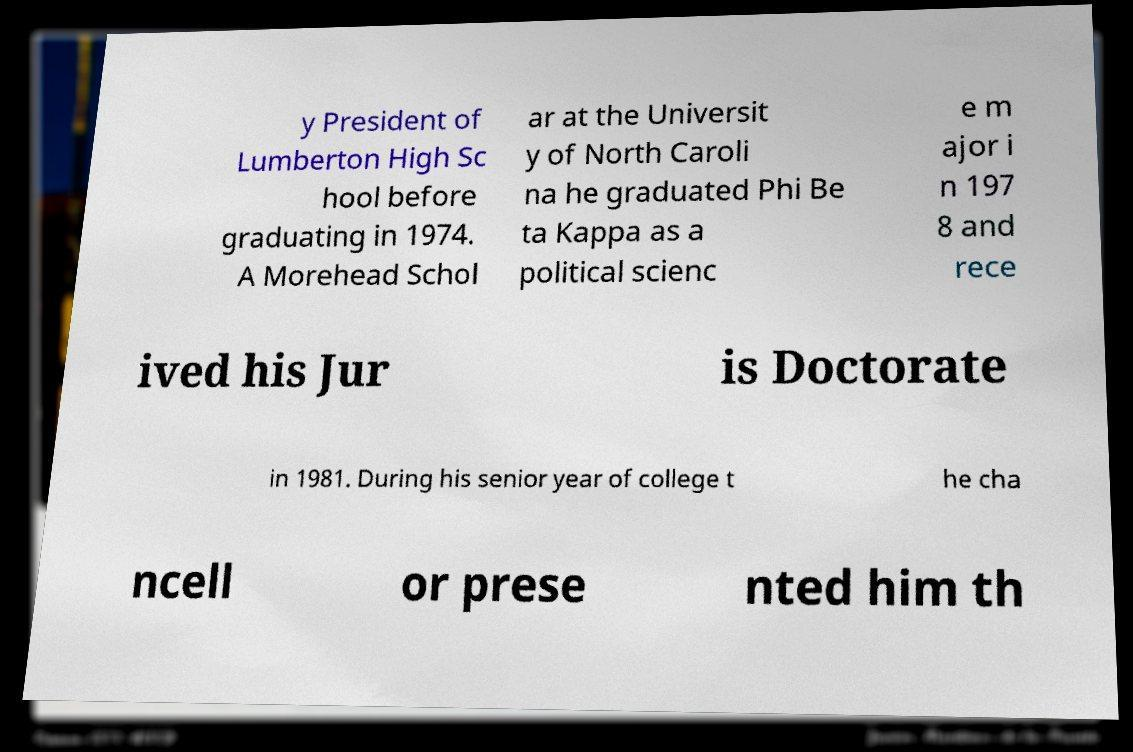Please read and relay the text visible in this image. What does it say? y President of Lumberton High Sc hool before graduating in 1974. A Morehead Schol ar at the Universit y of North Caroli na he graduated Phi Be ta Kappa as a political scienc e m ajor i n 197 8 and rece ived his Jur is Doctorate in 1981. During his senior year of college t he cha ncell or prese nted him th 